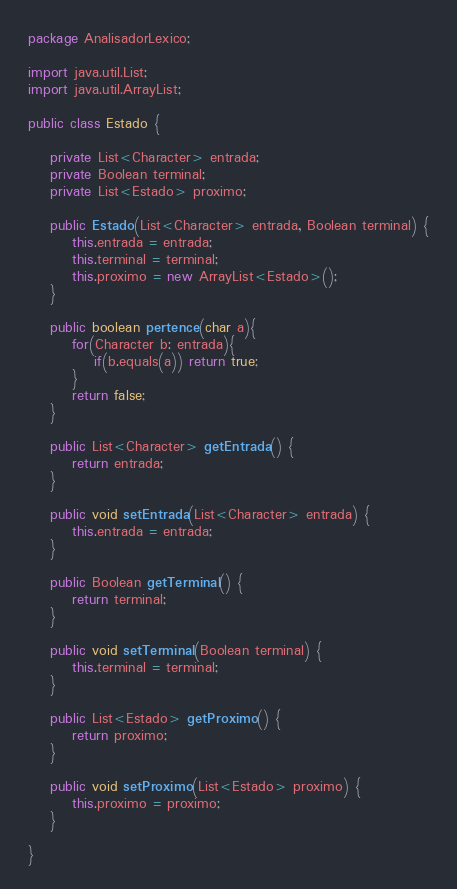<code> <loc_0><loc_0><loc_500><loc_500><_Java_>package AnalisadorLexico;

import java.util.List;
import java.util.ArrayList;

public class Estado {

	private List<Character> entrada;
	private Boolean terminal;
	private List<Estado> proximo;

	public Estado(List<Character> entrada, Boolean terminal) {
		this.entrada = entrada;
		this.terminal = terminal;
		this.proximo = new ArrayList<Estado>();
	}
	
	public boolean pertence(char a){
		for(Character b: entrada){
			if(b.equals(a)) return true;
		}
		return false;
	}

	public List<Character> getEntrada() {
		return entrada;
	}

	public void setEntrada(List<Character> entrada) {
		this.entrada = entrada;
	}

	public Boolean getTerminal() {
		return terminal;
	}

	public void setTerminal(Boolean terminal) {
		this.terminal = terminal;
	}

	public List<Estado> getProximo() {
		return proximo;
	}

	public void setProximo(List<Estado> proximo) {
		this.proximo = proximo;
	}	

}
</code> 